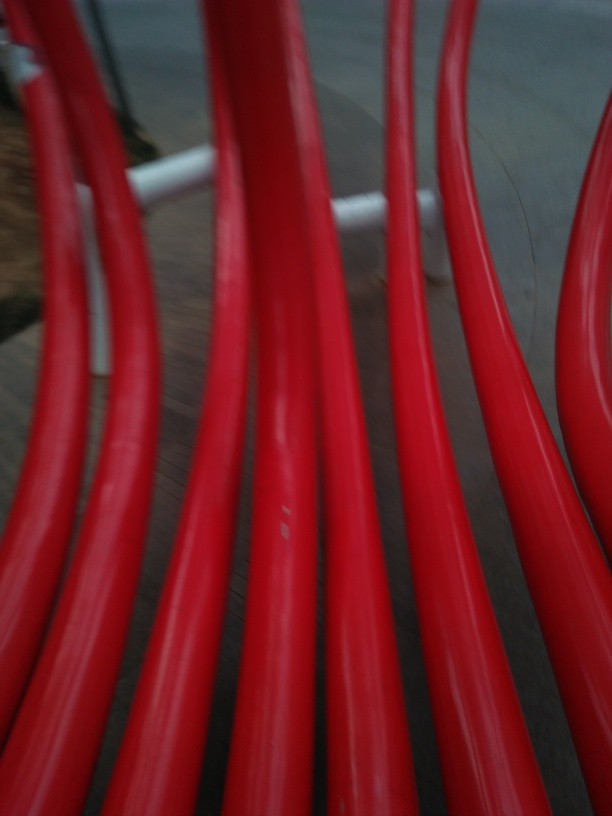Could you describe the color scheme of the image? The image predominantly features shades of red, which appear quite vivid. However, due to the focus issues, the colors blend and create a somewhat abstract appearance. 